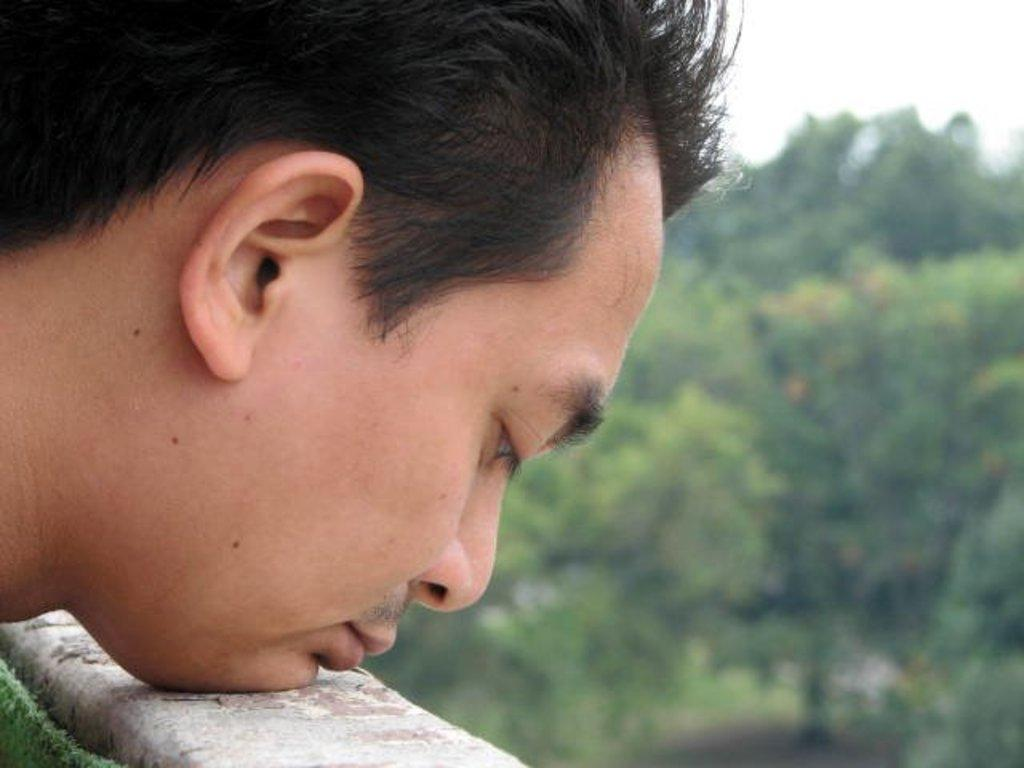What is the main subject of the image? There is a man's face in the image. Where is the man's face located? The man's face is on a wall. Can you describe the background of the image? The background of the image is blurred. How does the man escape from the quicksand in the image? There is no quicksand present in the image; it features a man's face on a wall with a blurred background. 